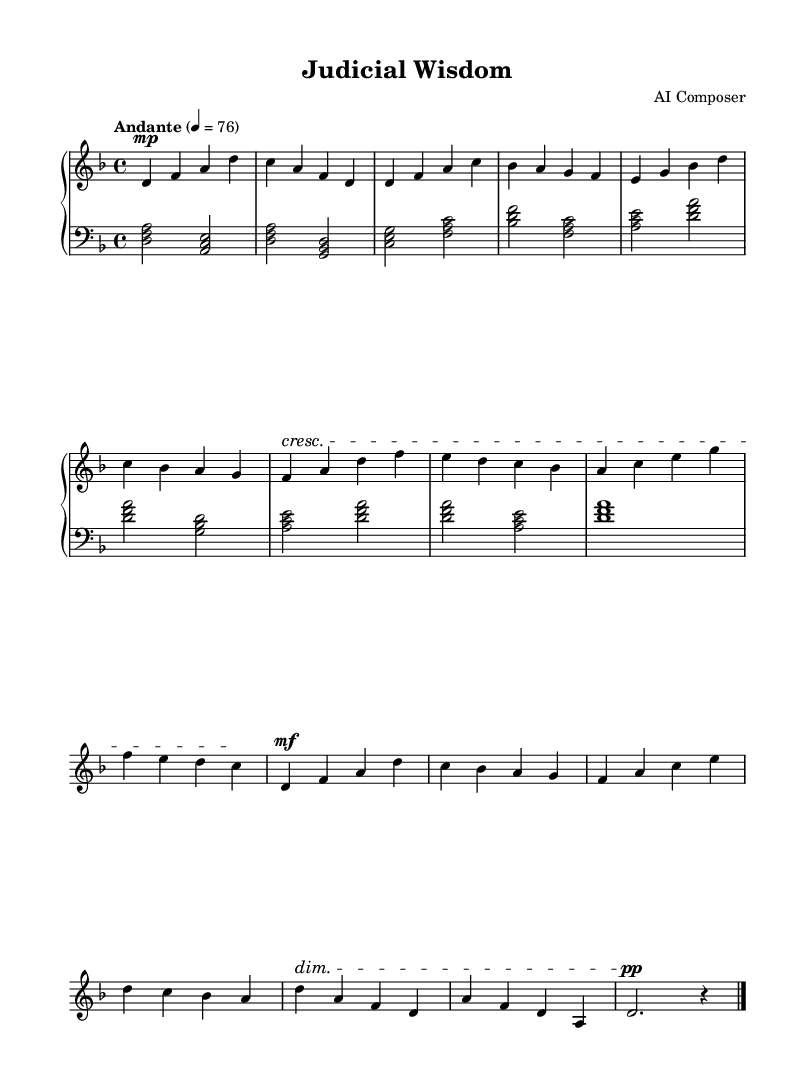What is the key signature of this piece? The key signature is D minor, which includes one flat (B flat). This can be identified from the information provided in the global context of the LilyPond code, where `\key d \minor` indicates the key.
Answer: D minor What is the time signature of this music? The time signature is 4/4, which means there are four beats in each measure and each quarter note gets one beat. This is indicated in the global context with `\time 4/4`.
Answer: 4/4 What is the tempo marking for this piece? The tempo marking is "Andante," which is a moderate pace. This is defined in the global context of the LilyPond code with the `\tempo` instruction.
Answer: Andante What is the dynamic marking at the beginning of the right hand section? The dynamic marking at the beginning of the right hand is "mp," indicating a moderato soft volume. This is found in the first measure of the right-hand music where `d4\mp` suggests the dynamic level.
Answer: mp How many sections are there in this piece? The piece consists of three main sections: Section A, Section B, and a variation of Section A (A'). The structure can be recognized through the labels "Section A," "Section B," and "Section A'" in the written music sections.
Answer: Three What dynamic change occurs in Section B? A crescendo occurs in Section B, indicating an increase in volume. This can be identified in the text `\crescTextCresc` before the measures of Section B, which suggests the gradual increase in loudness throughout this section.
Answer: Crescendo In which section does the music return to the original theme? The music returns to the original theme in Section A', which is noted as a variation of Section A. The specific designation of "Section A'" confirms it as a return to the original material from Section A.
Answer: Section A' 